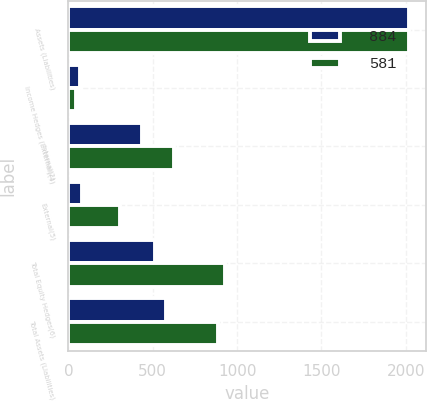Convert chart to OTSL. <chart><loc_0><loc_0><loc_500><loc_500><stacked_bar_chart><ecel><fcel>Assets (Liabilities)<fcel>Income Hedges (External)(4)<fcel>Internal(2)<fcel>External(5)<fcel>Total Equity Hedges(6)<fcel>Total Assets (Liabilities)<nl><fcel>884<fcel>2018<fcel>67<fcel>436<fcel>78<fcel>514<fcel>581<nl><fcel>581<fcel>2017<fcel>42<fcel>623<fcel>303<fcel>926<fcel>884<nl></chart> 